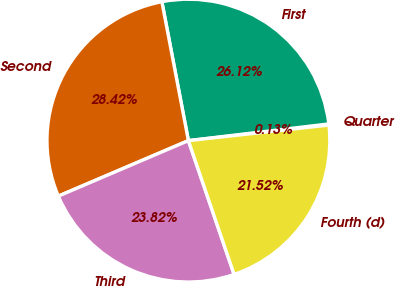Convert chart to OTSL. <chart><loc_0><loc_0><loc_500><loc_500><pie_chart><fcel>Quarter<fcel>First<fcel>Second<fcel>Third<fcel>Fourth (d)<nl><fcel>0.13%<fcel>26.12%<fcel>28.42%<fcel>23.82%<fcel>21.52%<nl></chart> 